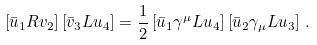<formula> <loc_0><loc_0><loc_500><loc_500>\left [ \bar { u } _ { 1 } R v _ { 2 } \right ] \left [ \bar { v } _ { 3 } L u _ { 4 } \right ] = \frac { 1 } { 2 } \left [ \bar { u } _ { 1 } \gamma ^ { \mu } L u _ { 4 } \right ] \left [ \bar { u } _ { 2 } \gamma _ { \mu } L u _ { 3 } \right ] \, .</formula> 